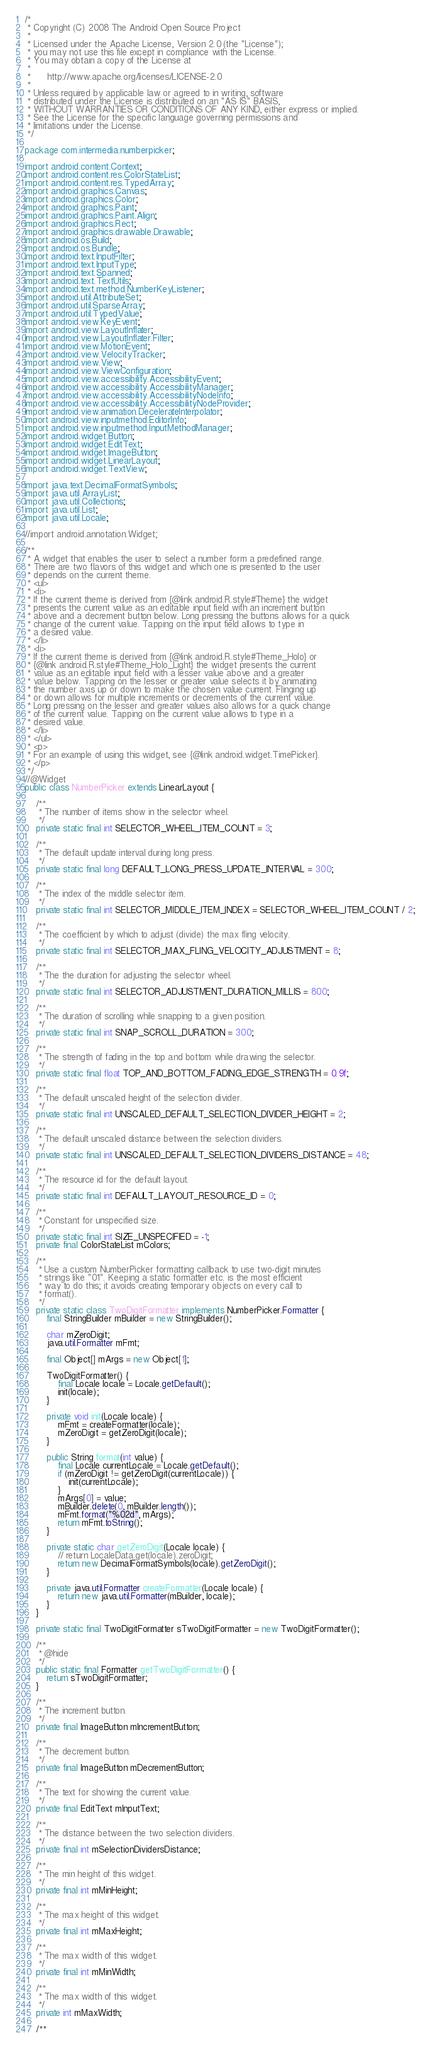<code> <loc_0><loc_0><loc_500><loc_500><_Java_>/*
 * Copyright (C) 2008 The Android Open Source Project
 *
 * Licensed under the Apache License, Version 2.0 (the "License");
 * you may not use this file except in compliance with the License.
 * You may obtain a copy of the License at
 *
 *      http://www.apache.org/licenses/LICENSE-2.0
 *
 * Unless required by applicable law or agreed to in writing, software
 * distributed under the License is distributed on an "AS IS" BASIS,
 * WITHOUT WARRANTIES OR CONDITIONS OF ANY KIND, either express or implied.
 * See the License for the specific language governing permissions and
 * limitations under the License.
 */

package com.intermedia.numberpicker;

import android.content.Context;
import android.content.res.ColorStateList;
import android.content.res.TypedArray;
import android.graphics.Canvas;
import android.graphics.Color;
import android.graphics.Paint;
import android.graphics.Paint.Align;
import android.graphics.Rect;
import android.graphics.drawable.Drawable;
import android.os.Build;
import android.os.Bundle;
import android.text.InputFilter;
import android.text.InputType;
import android.text.Spanned;
import android.text.TextUtils;
import android.text.method.NumberKeyListener;
import android.util.AttributeSet;
import android.util.SparseArray;
import android.util.TypedValue;
import android.view.KeyEvent;
import android.view.LayoutInflater;
import android.view.LayoutInflater.Filter;
import android.view.MotionEvent;
import android.view.VelocityTracker;
import android.view.View;
import android.view.ViewConfiguration;
import android.view.accessibility.AccessibilityEvent;
import android.view.accessibility.AccessibilityManager;
import android.view.accessibility.AccessibilityNodeInfo;
import android.view.accessibility.AccessibilityNodeProvider;
import android.view.animation.DecelerateInterpolator;
import android.view.inputmethod.EditorInfo;
import android.view.inputmethod.InputMethodManager;
import android.widget.Button;
import android.widget.EditText;
import android.widget.ImageButton;
import android.widget.LinearLayout;
import android.widget.TextView;

import java.text.DecimalFormatSymbols;
import java.util.ArrayList;
import java.util.Collections;
import java.util.List;
import java.util.Locale;

//import android.annotation.Widget;

/**
 * A widget that enables the user to select a number form a predefined range.
 * There are two flavors of this widget and which one is presented to the user
 * depends on the current theme.
 * <ul>
 * <li>
 * If the current theme is derived from {@link android.R.style#Theme} the widget
 * presents the current value as an editable input field with an increment button
 * above and a decrement button below. Long pressing the buttons allows for a quick
 * change of the current value. Tapping on the input field allows to type in
 * a desired value.
 * </li>
 * <li>
 * If the current theme is derived from {@link android.R.style#Theme_Holo} or
 * {@link android.R.style#Theme_Holo_Light} the widget presents the current
 * value as an editable input field with a lesser value above and a greater
 * value below. Tapping on the lesser or greater value selects it by animating
 * the number axis up or down to make the chosen value current. Flinging up
 * or down allows for multiple increments or decrements of the current value.
 * Long pressing on the lesser and greater values also allows for a quick change
 * of the current value. Tapping on the current value allows to type in a
 * desired value.
 * </li>
 * </ul>
 * <p>
 * For an example of using this widget, see {@link android.widget.TimePicker}.
 * </p>
 */
//@Widget
public class NumberPicker extends LinearLayout {

    /**
     * The number of items show in the selector wheel.
     */
    private static final int SELECTOR_WHEEL_ITEM_COUNT = 3;

    /**
     * The default update interval during long press.
     */
    private static final long DEFAULT_LONG_PRESS_UPDATE_INTERVAL = 300;

    /**
     * The index of the middle selector item.
     */
    private static final int SELECTOR_MIDDLE_ITEM_INDEX = SELECTOR_WHEEL_ITEM_COUNT / 2;

    /**
     * The coefficient by which to adjust (divide) the max fling velocity.
     */
    private static final int SELECTOR_MAX_FLING_VELOCITY_ADJUSTMENT = 8;

    /**
     * The the duration for adjusting the selector wheel.
     */
    private static final int SELECTOR_ADJUSTMENT_DURATION_MILLIS = 800;

    /**
     * The duration of scrolling while snapping to a given position.
     */
    private static final int SNAP_SCROLL_DURATION = 300;

    /**
     * The strength of fading in the top and bottom while drawing the selector.
     */
    private static final float TOP_AND_BOTTOM_FADING_EDGE_STRENGTH = 0.9f;

    /**
     * The default unscaled height of the selection divider.
     */
    private static final int UNSCALED_DEFAULT_SELECTION_DIVIDER_HEIGHT = 2;

    /**
     * The default unscaled distance between the selection dividers.
     */
    private static final int UNSCALED_DEFAULT_SELECTION_DIVIDERS_DISTANCE = 48;

    /**
     * The resource id for the default layout.
     */
    private static final int DEFAULT_LAYOUT_RESOURCE_ID = 0;

    /**
     * Constant for unspecified size.
     */
    private static final int SIZE_UNSPECIFIED = -1;
    private final ColorStateList mColors;

    /**
     * Use a custom NumberPicker formatting callback to use two-digit minutes
     * strings like "01". Keeping a static formatter etc. is the most efficient
     * way to do this; it avoids creating temporary objects on every call to
     * format().
     */
    private static class TwoDigitFormatter implements NumberPicker.Formatter {
        final StringBuilder mBuilder = new StringBuilder();

        char mZeroDigit;
        java.util.Formatter mFmt;

        final Object[] mArgs = new Object[1];

        TwoDigitFormatter() {
            final Locale locale = Locale.getDefault();
            init(locale);
        }

        private void init(Locale locale) {
            mFmt = createFormatter(locale);
            mZeroDigit = getZeroDigit(locale);
        }

        public String format(int value) {
            final Locale currentLocale = Locale.getDefault();
            if (mZeroDigit != getZeroDigit(currentLocale)) {
                init(currentLocale);
            }
            mArgs[0] = value;
            mBuilder.delete(0, mBuilder.length());
            mFmt.format("%02d", mArgs);
            return mFmt.toString();
        }

        private static char getZeroDigit(Locale locale) {
            // return LocaleData.get(locale).zeroDigit;
            return new DecimalFormatSymbols(locale).getZeroDigit();
        }

        private java.util.Formatter createFormatter(Locale locale) {
            return new java.util.Formatter(mBuilder, locale);
        }
    }

    private static final TwoDigitFormatter sTwoDigitFormatter = new TwoDigitFormatter();

    /**
     * @hide
     */
    public static final Formatter getTwoDigitFormatter() {
        return sTwoDigitFormatter;
    }

    /**
     * The increment button.
     */
    private final ImageButton mIncrementButton;

    /**
     * The decrement button.
     */
    private final ImageButton mDecrementButton;

    /**
     * The text for showing the current value.
     */
    private final EditText mInputText;

    /**
     * The distance between the two selection dividers.
     */
    private final int mSelectionDividersDistance;

    /**
     * The min height of this widget.
     */
    private final int mMinHeight;

    /**
     * The max height of this widget.
     */
    private final int mMaxHeight;

    /**
     * The max width of this widget.
     */
    private final int mMinWidth;

    /**
     * The max width of this widget.
     */
    private int mMaxWidth;

    /**</code> 